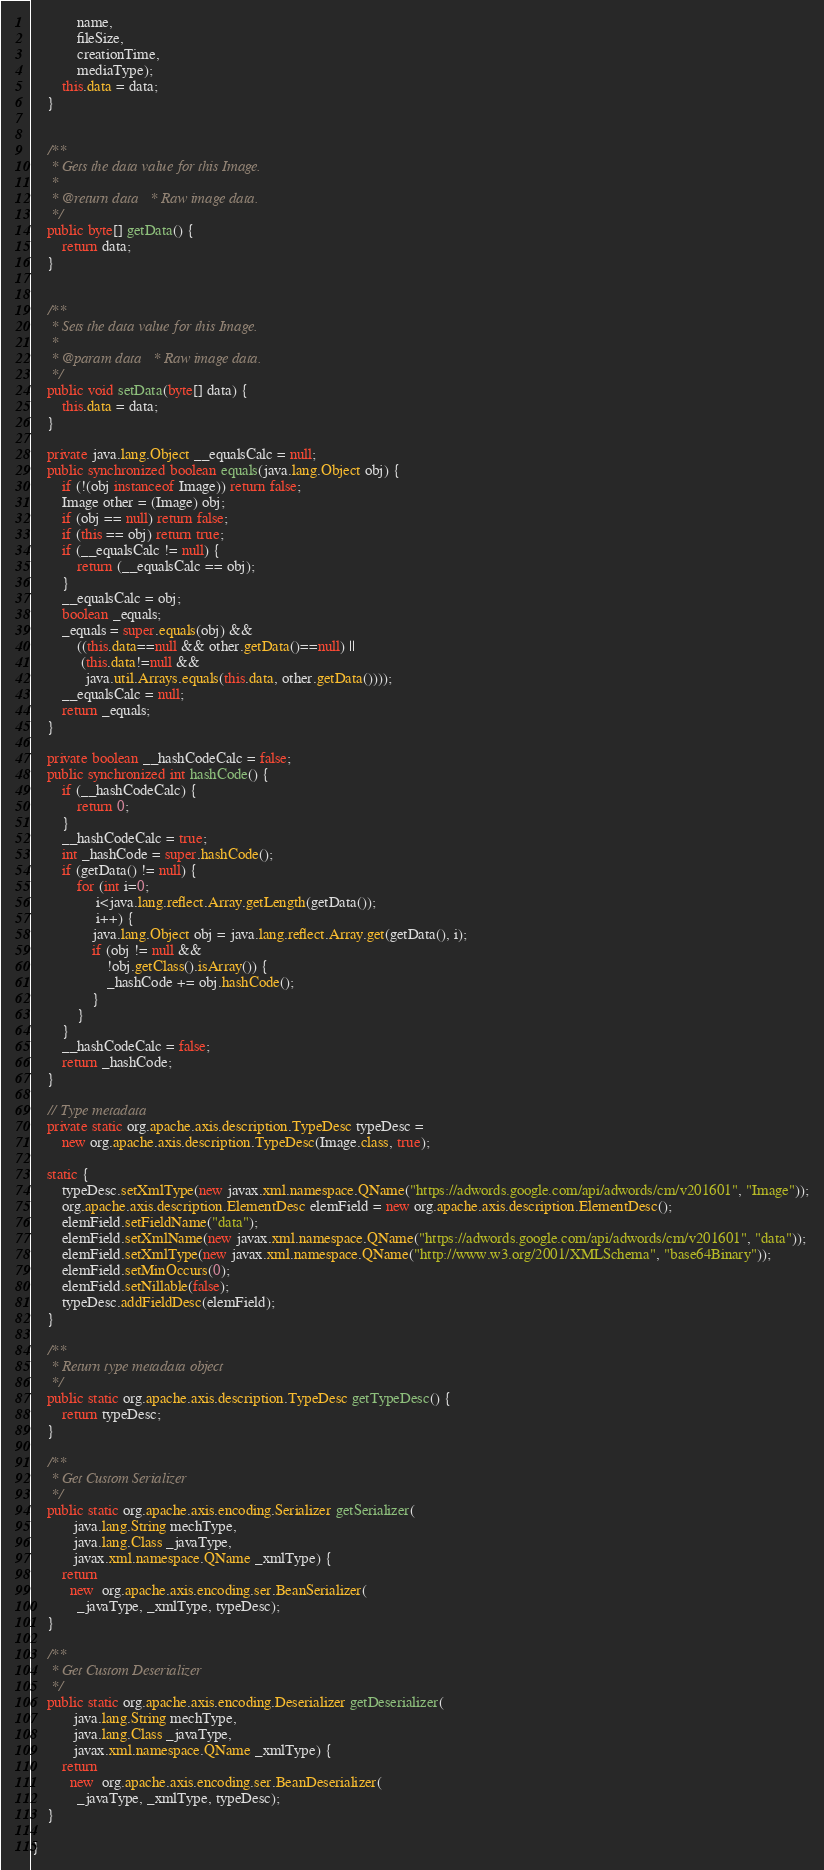Convert code to text. <code><loc_0><loc_0><loc_500><loc_500><_Java_>            name,
            fileSize,
            creationTime,
            mediaType);
        this.data = data;
    }


    /**
     * Gets the data value for this Image.
     * 
     * @return data   * Raw image data.
     */
    public byte[] getData() {
        return data;
    }


    /**
     * Sets the data value for this Image.
     * 
     * @param data   * Raw image data.
     */
    public void setData(byte[] data) {
        this.data = data;
    }

    private java.lang.Object __equalsCalc = null;
    public synchronized boolean equals(java.lang.Object obj) {
        if (!(obj instanceof Image)) return false;
        Image other = (Image) obj;
        if (obj == null) return false;
        if (this == obj) return true;
        if (__equalsCalc != null) {
            return (__equalsCalc == obj);
        }
        __equalsCalc = obj;
        boolean _equals;
        _equals = super.equals(obj) && 
            ((this.data==null && other.getData()==null) || 
             (this.data!=null &&
              java.util.Arrays.equals(this.data, other.getData())));
        __equalsCalc = null;
        return _equals;
    }

    private boolean __hashCodeCalc = false;
    public synchronized int hashCode() {
        if (__hashCodeCalc) {
            return 0;
        }
        __hashCodeCalc = true;
        int _hashCode = super.hashCode();
        if (getData() != null) {
            for (int i=0;
                 i<java.lang.reflect.Array.getLength(getData());
                 i++) {
                java.lang.Object obj = java.lang.reflect.Array.get(getData(), i);
                if (obj != null &&
                    !obj.getClass().isArray()) {
                    _hashCode += obj.hashCode();
                }
            }
        }
        __hashCodeCalc = false;
        return _hashCode;
    }

    // Type metadata
    private static org.apache.axis.description.TypeDesc typeDesc =
        new org.apache.axis.description.TypeDesc(Image.class, true);

    static {
        typeDesc.setXmlType(new javax.xml.namespace.QName("https://adwords.google.com/api/adwords/cm/v201601", "Image"));
        org.apache.axis.description.ElementDesc elemField = new org.apache.axis.description.ElementDesc();
        elemField.setFieldName("data");
        elemField.setXmlName(new javax.xml.namespace.QName("https://adwords.google.com/api/adwords/cm/v201601", "data"));
        elemField.setXmlType(new javax.xml.namespace.QName("http://www.w3.org/2001/XMLSchema", "base64Binary"));
        elemField.setMinOccurs(0);
        elemField.setNillable(false);
        typeDesc.addFieldDesc(elemField);
    }

    /**
     * Return type metadata object
     */
    public static org.apache.axis.description.TypeDesc getTypeDesc() {
        return typeDesc;
    }

    /**
     * Get Custom Serializer
     */
    public static org.apache.axis.encoding.Serializer getSerializer(
           java.lang.String mechType, 
           java.lang.Class _javaType,  
           javax.xml.namespace.QName _xmlType) {
        return 
          new  org.apache.axis.encoding.ser.BeanSerializer(
            _javaType, _xmlType, typeDesc);
    }

    /**
     * Get Custom Deserializer
     */
    public static org.apache.axis.encoding.Deserializer getDeserializer(
           java.lang.String mechType, 
           java.lang.Class _javaType,  
           javax.xml.namespace.QName _xmlType) {
        return 
          new  org.apache.axis.encoding.ser.BeanDeserializer(
            _javaType, _xmlType, typeDesc);
    }

}
</code> 